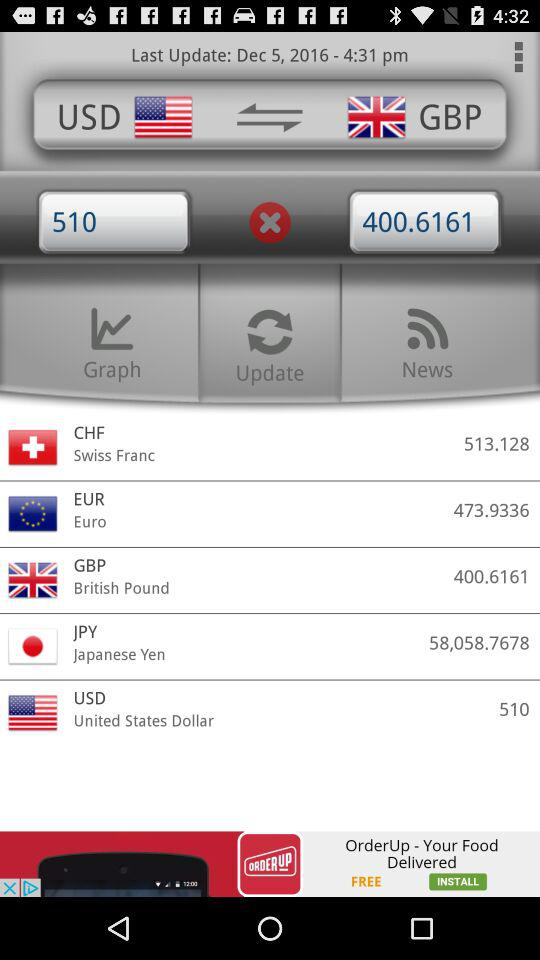How much GBP is equal to 510 USD? 510 USD is equal to 400.6161 GBP. 